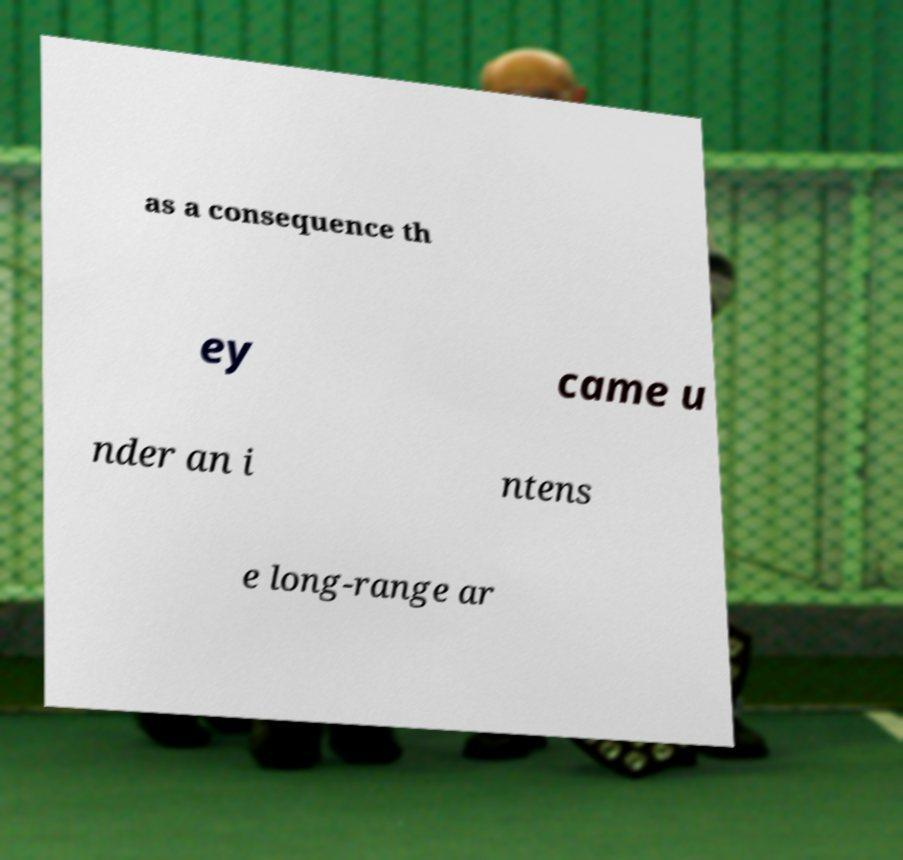Please identify and transcribe the text found in this image. as a consequence th ey came u nder an i ntens e long-range ar 